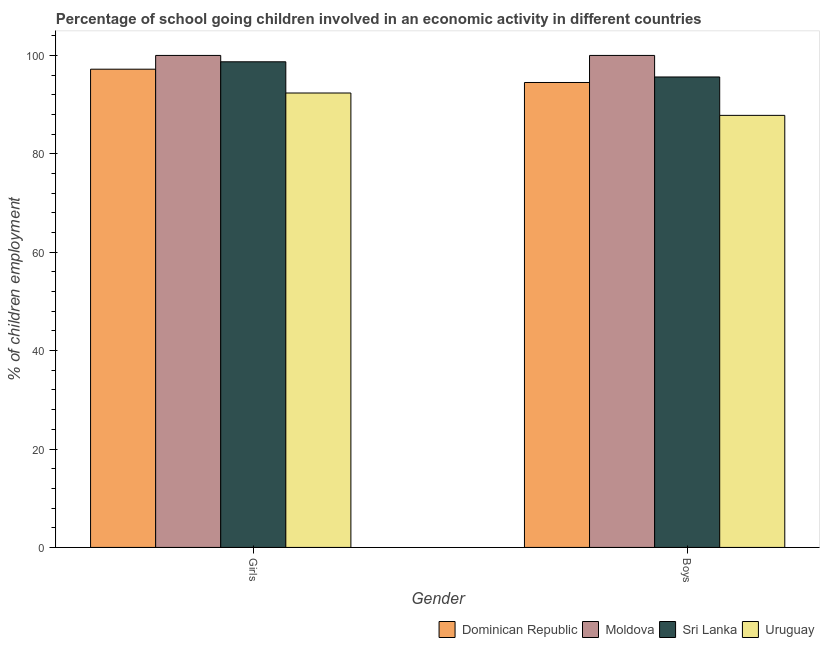Are the number of bars per tick equal to the number of legend labels?
Your answer should be very brief. Yes. How many bars are there on the 1st tick from the right?
Provide a succinct answer. 4. What is the label of the 1st group of bars from the left?
Your answer should be very brief. Girls. Across all countries, what is the minimum percentage of school going girls?
Ensure brevity in your answer.  92.36. In which country was the percentage of school going boys maximum?
Offer a very short reply. Moldova. In which country was the percentage of school going boys minimum?
Ensure brevity in your answer.  Uruguay. What is the total percentage of school going boys in the graph?
Offer a terse response. 377.94. What is the difference between the percentage of school going girls in Moldova and that in Uruguay?
Ensure brevity in your answer.  7.64. What is the difference between the percentage of school going boys in Sri Lanka and the percentage of school going girls in Moldova?
Keep it short and to the point. -4.38. What is the average percentage of school going girls per country?
Your answer should be compact. 97.07. What is the difference between the percentage of school going girls and percentage of school going boys in Sri Lanka?
Offer a terse response. 3.08. In how many countries, is the percentage of school going boys greater than 96 %?
Offer a very short reply. 1. What is the ratio of the percentage of school going girls in Sri Lanka to that in Dominican Republic?
Your answer should be compact. 1.02. Is the percentage of school going boys in Uruguay less than that in Moldova?
Provide a succinct answer. Yes. What does the 1st bar from the left in Boys represents?
Make the answer very short. Dominican Republic. What does the 1st bar from the right in Boys represents?
Provide a short and direct response. Uruguay. How many bars are there?
Your answer should be compact. 8. How many countries are there in the graph?
Offer a terse response. 4. Does the graph contain any zero values?
Ensure brevity in your answer.  No. How are the legend labels stacked?
Provide a short and direct response. Horizontal. What is the title of the graph?
Provide a short and direct response. Percentage of school going children involved in an economic activity in different countries. Does "Belize" appear as one of the legend labels in the graph?
Give a very brief answer. No. What is the label or title of the Y-axis?
Provide a succinct answer. % of children employment. What is the % of children employment of Dominican Republic in Girls?
Your answer should be compact. 97.2. What is the % of children employment of Sri Lanka in Girls?
Give a very brief answer. 98.71. What is the % of children employment in Uruguay in Girls?
Offer a very short reply. 92.36. What is the % of children employment of Dominican Republic in Boys?
Provide a short and direct response. 94.5. What is the % of children employment of Moldova in Boys?
Give a very brief answer. 100. What is the % of children employment in Sri Lanka in Boys?
Give a very brief answer. 95.62. What is the % of children employment of Uruguay in Boys?
Give a very brief answer. 87.82. Across all Gender, what is the maximum % of children employment of Dominican Republic?
Give a very brief answer. 97.2. Across all Gender, what is the maximum % of children employment of Sri Lanka?
Provide a short and direct response. 98.71. Across all Gender, what is the maximum % of children employment in Uruguay?
Offer a very short reply. 92.36. Across all Gender, what is the minimum % of children employment in Dominican Republic?
Give a very brief answer. 94.5. Across all Gender, what is the minimum % of children employment of Moldova?
Your response must be concise. 100. Across all Gender, what is the minimum % of children employment of Sri Lanka?
Offer a very short reply. 95.62. Across all Gender, what is the minimum % of children employment of Uruguay?
Provide a succinct answer. 87.82. What is the total % of children employment in Dominican Republic in the graph?
Provide a succinct answer. 191.7. What is the total % of children employment of Sri Lanka in the graph?
Keep it short and to the point. 194.33. What is the total % of children employment in Uruguay in the graph?
Your answer should be very brief. 180.18. What is the difference between the % of children employment in Sri Lanka in Girls and that in Boys?
Give a very brief answer. 3.08. What is the difference between the % of children employment in Uruguay in Girls and that in Boys?
Keep it short and to the point. 4.54. What is the difference between the % of children employment of Dominican Republic in Girls and the % of children employment of Moldova in Boys?
Make the answer very short. -2.8. What is the difference between the % of children employment of Dominican Republic in Girls and the % of children employment of Sri Lanka in Boys?
Your answer should be compact. 1.58. What is the difference between the % of children employment in Dominican Republic in Girls and the % of children employment in Uruguay in Boys?
Keep it short and to the point. 9.38. What is the difference between the % of children employment of Moldova in Girls and the % of children employment of Sri Lanka in Boys?
Your answer should be very brief. 4.38. What is the difference between the % of children employment in Moldova in Girls and the % of children employment in Uruguay in Boys?
Ensure brevity in your answer.  12.18. What is the difference between the % of children employment of Sri Lanka in Girls and the % of children employment of Uruguay in Boys?
Your answer should be very brief. 10.89. What is the average % of children employment in Dominican Republic per Gender?
Offer a terse response. 95.85. What is the average % of children employment in Moldova per Gender?
Your answer should be very brief. 100. What is the average % of children employment of Sri Lanka per Gender?
Your answer should be very brief. 97.16. What is the average % of children employment in Uruguay per Gender?
Make the answer very short. 90.09. What is the difference between the % of children employment in Dominican Republic and % of children employment in Sri Lanka in Girls?
Offer a terse response. -1.5. What is the difference between the % of children employment in Dominican Republic and % of children employment in Uruguay in Girls?
Offer a very short reply. 4.84. What is the difference between the % of children employment in Moldova and % of children employment in Sri Lanka in Girls?
Ensure brevity in your answer.  1.29. What is the difference between the % of children employment of Moldova and % of children employment of Uruguay in Girls?
Provide a short and direct response. 7.64. What is the difference between the % of children employment in Sri Lanka and % of children employment in Uruguay in Girls?
Give a very brief answer. 6.35. What is the difference between the % of children employment in Dominican Republic and % of children employment in Sri Lanka in Boys?
Your answer should be compact. -1.12. What is the difference between the % of children employment in Dominican Republic and % of children employment in Uruguay in Boys?
Provide a short and direct response. 6.68. What is the difference between the % of children employment in Moldova and % of children employment in Sri Lanka in Boys?
Provide a short and direct response. 4.38. What is the difference between the % of children employment of Moldova and % of children employment of Uruguay in Boys?
Your answer should be very brief. 12.18. What is the difference between the % of children employment of Sri Lanka and % of children employment of Uruguay in Boys?
Your response must be concise. 7.8. What is the ratio of the % of children employment of Dominican Republic in Girls to that in Boys?
Give a very brief answer. 1.03. What is the ratio of the % of children employment of Sri Lanka in Girls to that in Boys?
Keep it short and to the point. 1.03. What is the ratio of the % of children employment of Uruguay in Girls to that in Boys?
Keep it short and to the point. 1.05. What is the difference between the highest and the second highest % of children employment in Moldova?
Make the answer very short. 0. What is the difference between the highest and the second highest % of children employment of Sri Lanka?
Ensure brevity in your answer.  3.08. What is the difference between the highest and the second highest % of children employment in Uruguay?
Provide a succinct answer. 4.54. What is the difference between the highest and the lowest % of children employment of Moldova?
Give a very brief answer. 0. What is the difference between the highest and the lowest % of children employment of Sri Lanka?
Make the answer very short. 3.08. What is the difference between the highest and the lowest % of children employment of Uruguay?
Ensure brevity in your answer.  4.54. 